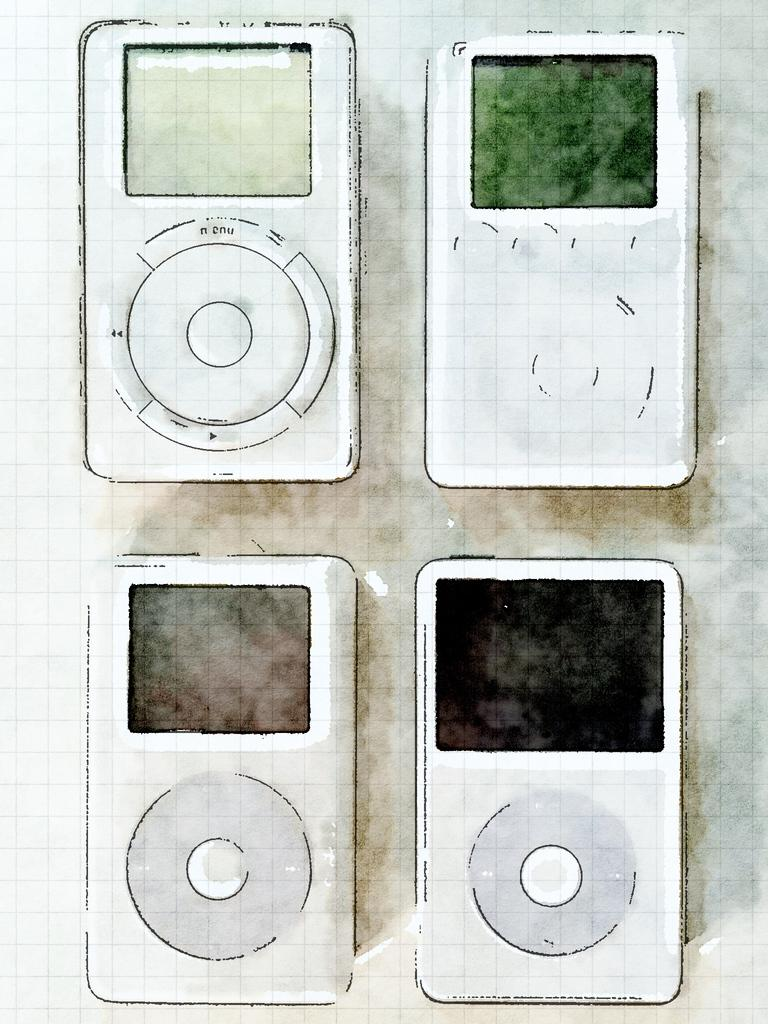How many iPods are depicted in the image? There are four different images of iPods in the picture. What type of brush is used to polish the iPods in the image? There is no brush or polishing activity depicted in the image; it only shows four different images of iPods. 